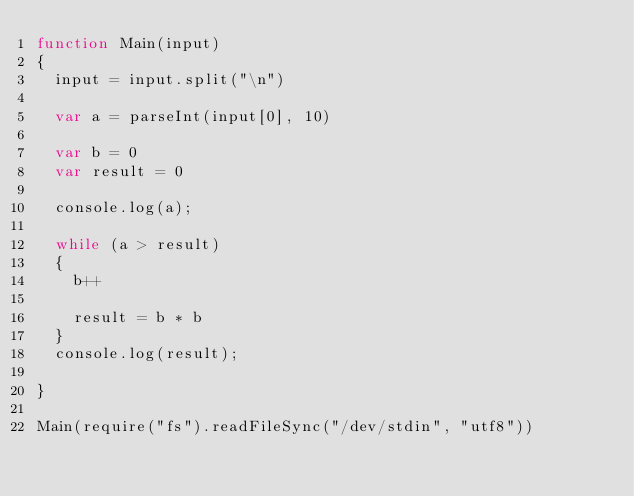Convert code to text. <code><loc_0><loc_0><loc_500><loc_500><_JavaScript_>function Main(input)
{
	input = input.split("\n")

  var a = parseInt(input[0], 10)

  var b = 0
  var result = 0

  console.log(a);

  while (a > result)
  {
    b++

    result = b * b
  }
  console.log(result);

}

Main(require("fs").readFileSync("/dev/stdin", "utf8"))
</code> 